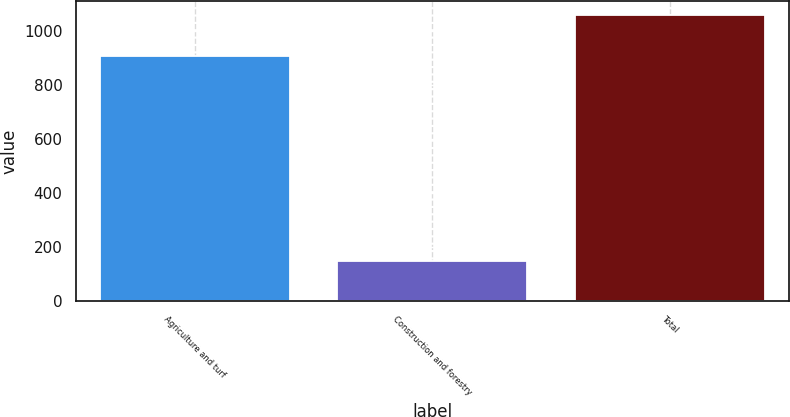<chart> <loc_0><loc_0><loc_500><loc_500><bar_chart><fcel>Agriculture and turf<fcel>Construction and forestry<fcel>Total<nl><fcel>909<fcel>148<fcel>1059<nl></chart> 